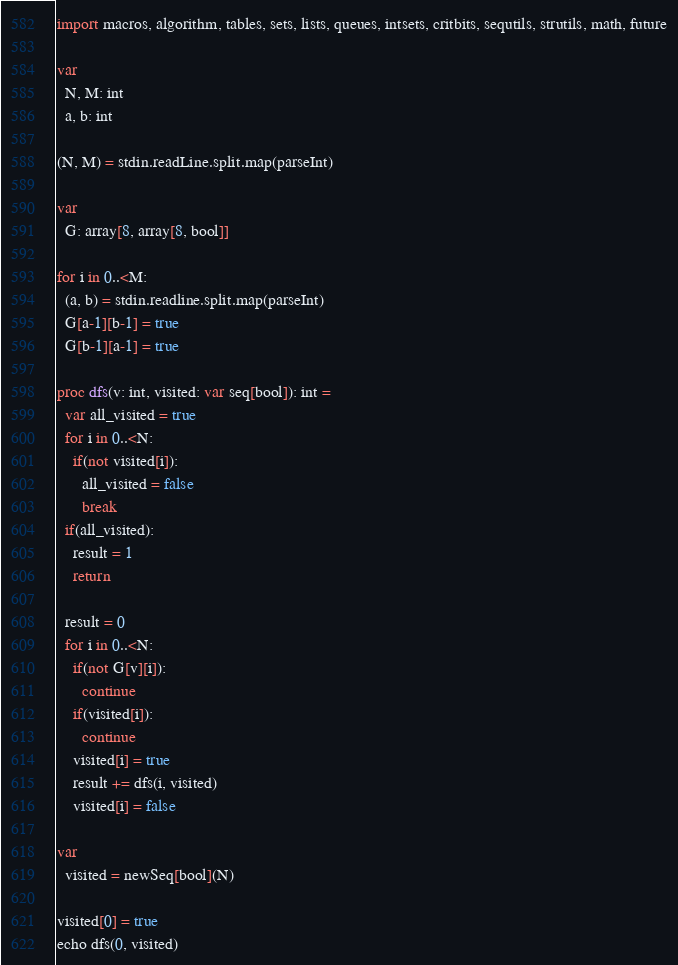<code> <loc_0><loc_0><loc_500><loc_500><_Nim_>import macros, algorithm, tables, sets, lists, queues, intsets, critbits, sequtils, strutils, math, future

var
  N, M: int
  a, b: int

(N, M) = stdin.readLine.split.map(parseInt)

var
  G: array[8, array[8, bool]]

for i in 0..<M:
  (a, b) = stdin.readline.split.map(parseInt)
  G[a-1][b-1] = true
  G[b-1][a-1] = true

proc dfs(v: int, visited: var seq[bool]): int =
  var all_visited = true
  for i in 0..<N:
    if(not visited[i]):
      all_visited = false
      break
  if(all_visited):
    result = 1
    return

  result = 0
  for i in 0..<N:
    if(not G[v][i]):
      continue
    if(visited[i]):
      continue
    visited[i] = true
    result += dfs(i, visited)
    visited[i] = false

var
  visited = newSeq[bool](N)

visited[0] = true
echo dfs(0, visited)
</code> 